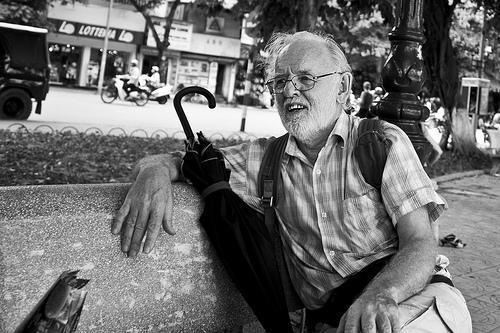How many bikes are in the background?
Give a very brief answer. 2. How many colors are in the picture?
Give a very brief answer. 2. How many glasses are in the picture?
Give a very brief answer. 1. How many people carry umbrella?
Give a very brief answer. 1. 